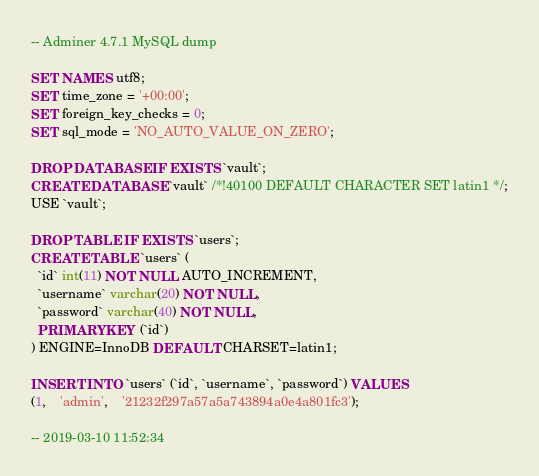Convert code to text. <code><loc_0><loc_0><loc_500><loc_500><_SQL_>-- Adminer 4.7.1 MySQL dump

SET NAMES utf8;
SET time_zone = '+00:00';
SET foreign_key_checks = 0;
SET sql_mode = 'NO_AUTO_VALUE_ON_ZERO';

DROP DATABASE IF EXISTS `vault`;
CREATE DATABASE `vault` /*!40100 DEFAULT CHARACTER SET latin1 */;
USE `vault`;

DROP TABLE IF EXISTS `users`;
CREATE TABLE `users` (
  `id` int(11) NOT NULL AUTO_INCREMENT,
  `username` varchar(20) NOT NULL,
  `password` varchar(40) NOT NULL,
  PRIMARY KEY (`id`)
) ENGINE=InnoDB DEFAULT CHARSET=latin1;

INSERT INTO `users` (`id`, `username`, `password`) VALUES
(1,	'admin',	'21232f297a57a5a743894a0e4a801fc3');

-- 2019-03-10 11:52:34
</code> 